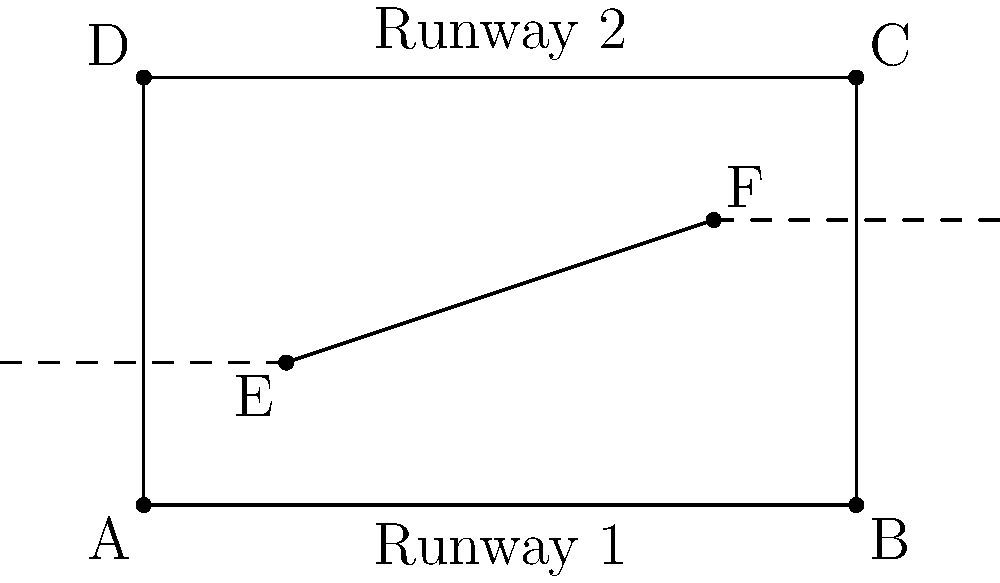Two parallel runways on a military base are represented by lines AD and BC in the diagram. Point E (1,1) is on the first runway, and point F (4,2) is on the second runway. Calculate the shortest distance between these two runways. To find the shortest distance between two parallel lines, we need to:

1) Find the equation of the line passing through points E and F.
   Slope = $\frac{y_2 - y_1}{x_2 - x_1} = \frac{2-1}{4-1} = \frac{1}{3}$
   Equation: $y - 1 = \frac{1}{3}(x - 1)$ or $y = \frac{1}{3}x + \frac{2}{3}$

2) Find the equation of the perpendicular line passing through E.
   Perpendicular slope = $-3$ (negative reciprocal of $\frac{1}{3}$)
   Equation: $y - 1 = -3(x - 1)$ or $y = -3x + 4$

3) Find the intersection point of this perpendicular line with the second runway (line BC).
   Line BC: $y = 3$
   Solving: $3 = -3x + 4$
            $x = \frac{1}{3}$
   Intersection point: $(\frac{1}{3}, 3)$

4) Calculate the distance between E $(1, 1)$ and $(\frac{1}{3}, 3)$.
   Distance = $\sqrt{(x_2 - x_1)^2 + (y_2 - y_1)^2}$
             $= \sqrt{(\frac{1}{3} - 1)^2 + (3 - 1)^2}$
             $= \sqrt{(\frac{-2}{3})^2 + 2^2}$
             $= \sqrt{\frac{4}{9} + 4}$
             $= \sqrt{\frac{40}{9}}$
             $= \frac{2\sqrt{10}}{3}$

Therefore, the shortest distance between the two runways is $\frac{2\sqrt{10}}{3}$ units.
Answer: $\frac{2\sqrt{10}}{3}$ units 